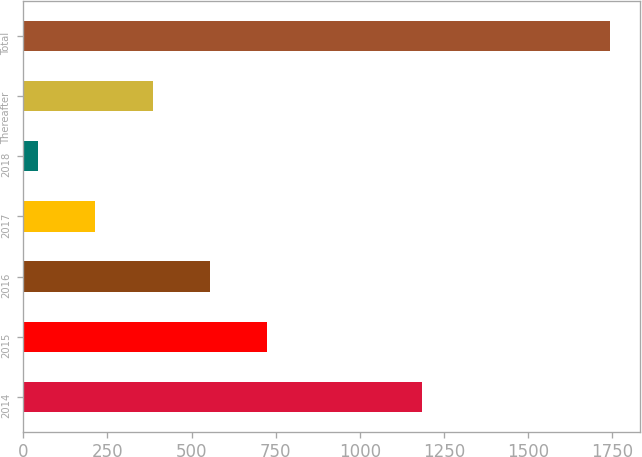<chart> <loc_0><loc_0><loc_500><loc_500><bar_chart><fcel>2014<fcel>2015<fcel>2016<fcel>2017<fcel>2018<fcel>Thereafter<fcel>Total<nl><fcel>1183<fcel>724<fcel>554<fcel>214<fcel>44<fcel>384<fcel>1744<nl></chart> 